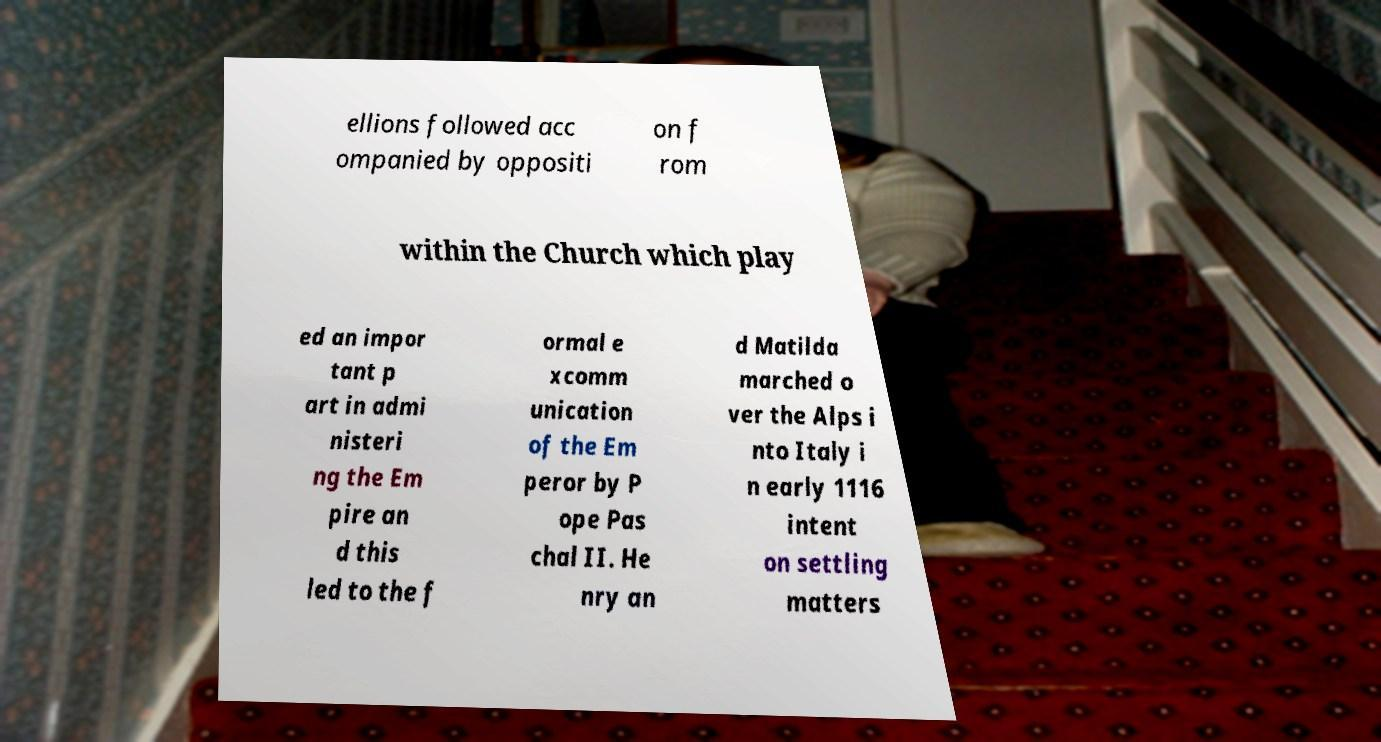For documentation purposes, I need the text within this image transcribed. Could you provide that? ellions followed acc ompanied by oppositi on f rom within the Church which play ed an impor tant p art in admi nisteri ng the Em pire an d this led to the f ormal e xcomm unication of the Em peror by P ope Pas chal II. He nry an d Matilda marched o ver the Alps i nto Italy i n early 1116 intent on settling matters 